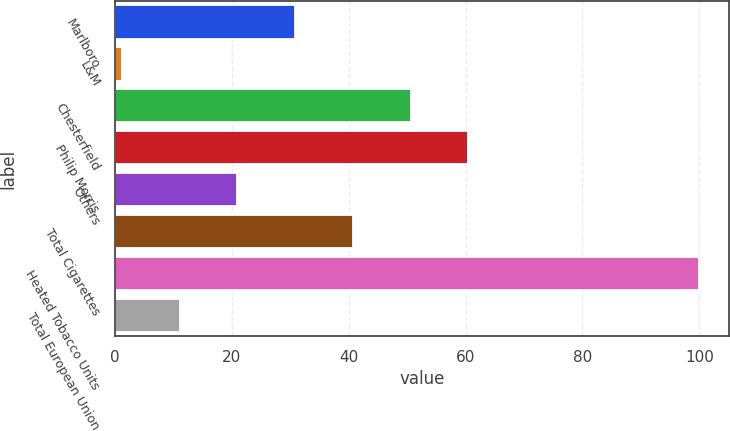<chart> <loc_0><loc_0><loc_500><loc_500><bar_chart><fcel>Marlboro<fcel>L&M<fcel>Chesterfield<fcel>Philip Morris<fcel>Others<fcel>Total Cigarettes<fcel>Heated Tobacco Units<fcel>Total European Union<nl><fcel>30.84<fcel>1.2<fcel>50.6<fcel>60.48<fcel>20.96<fcel>40.72<fcel>100<fcel>11.08<nl></chart> 